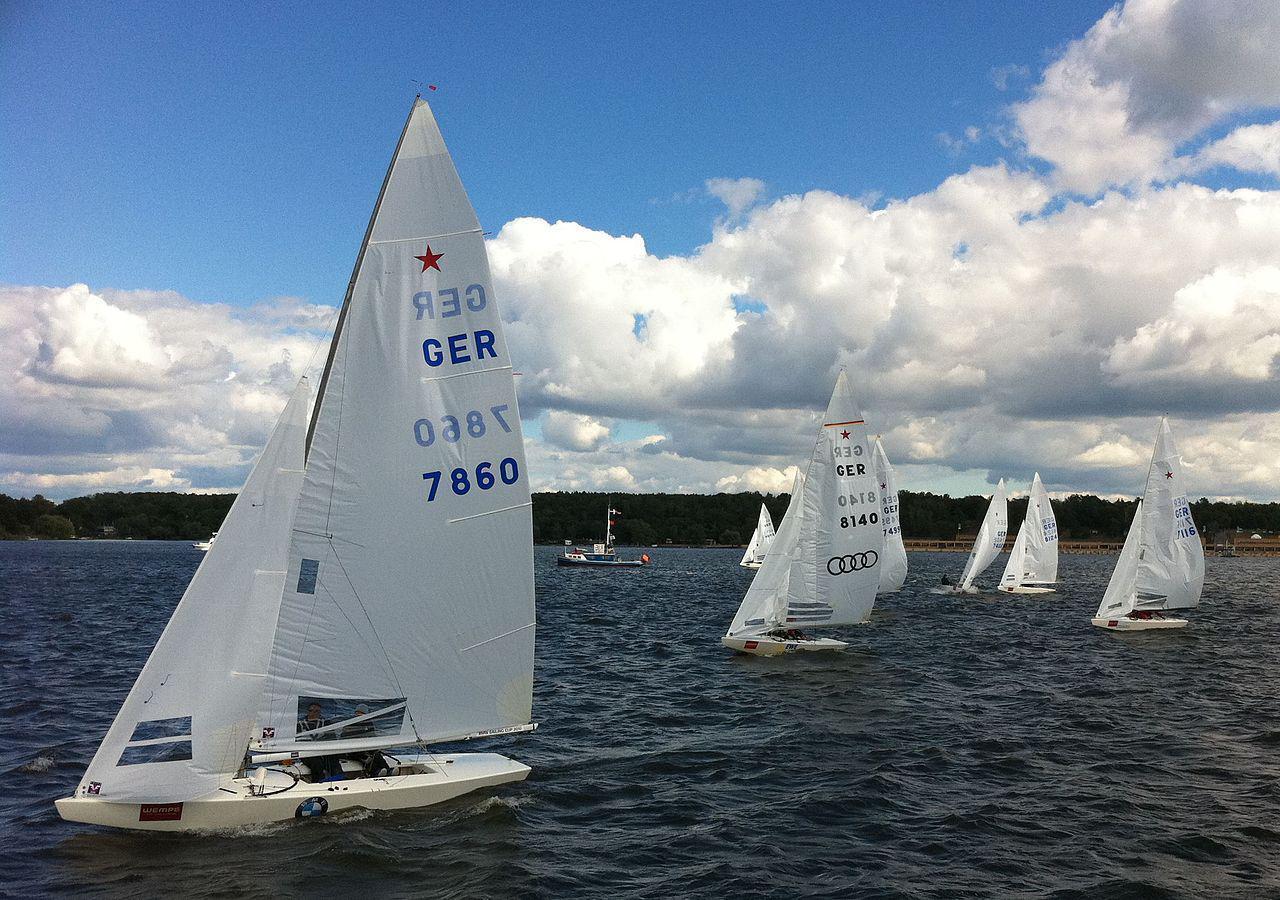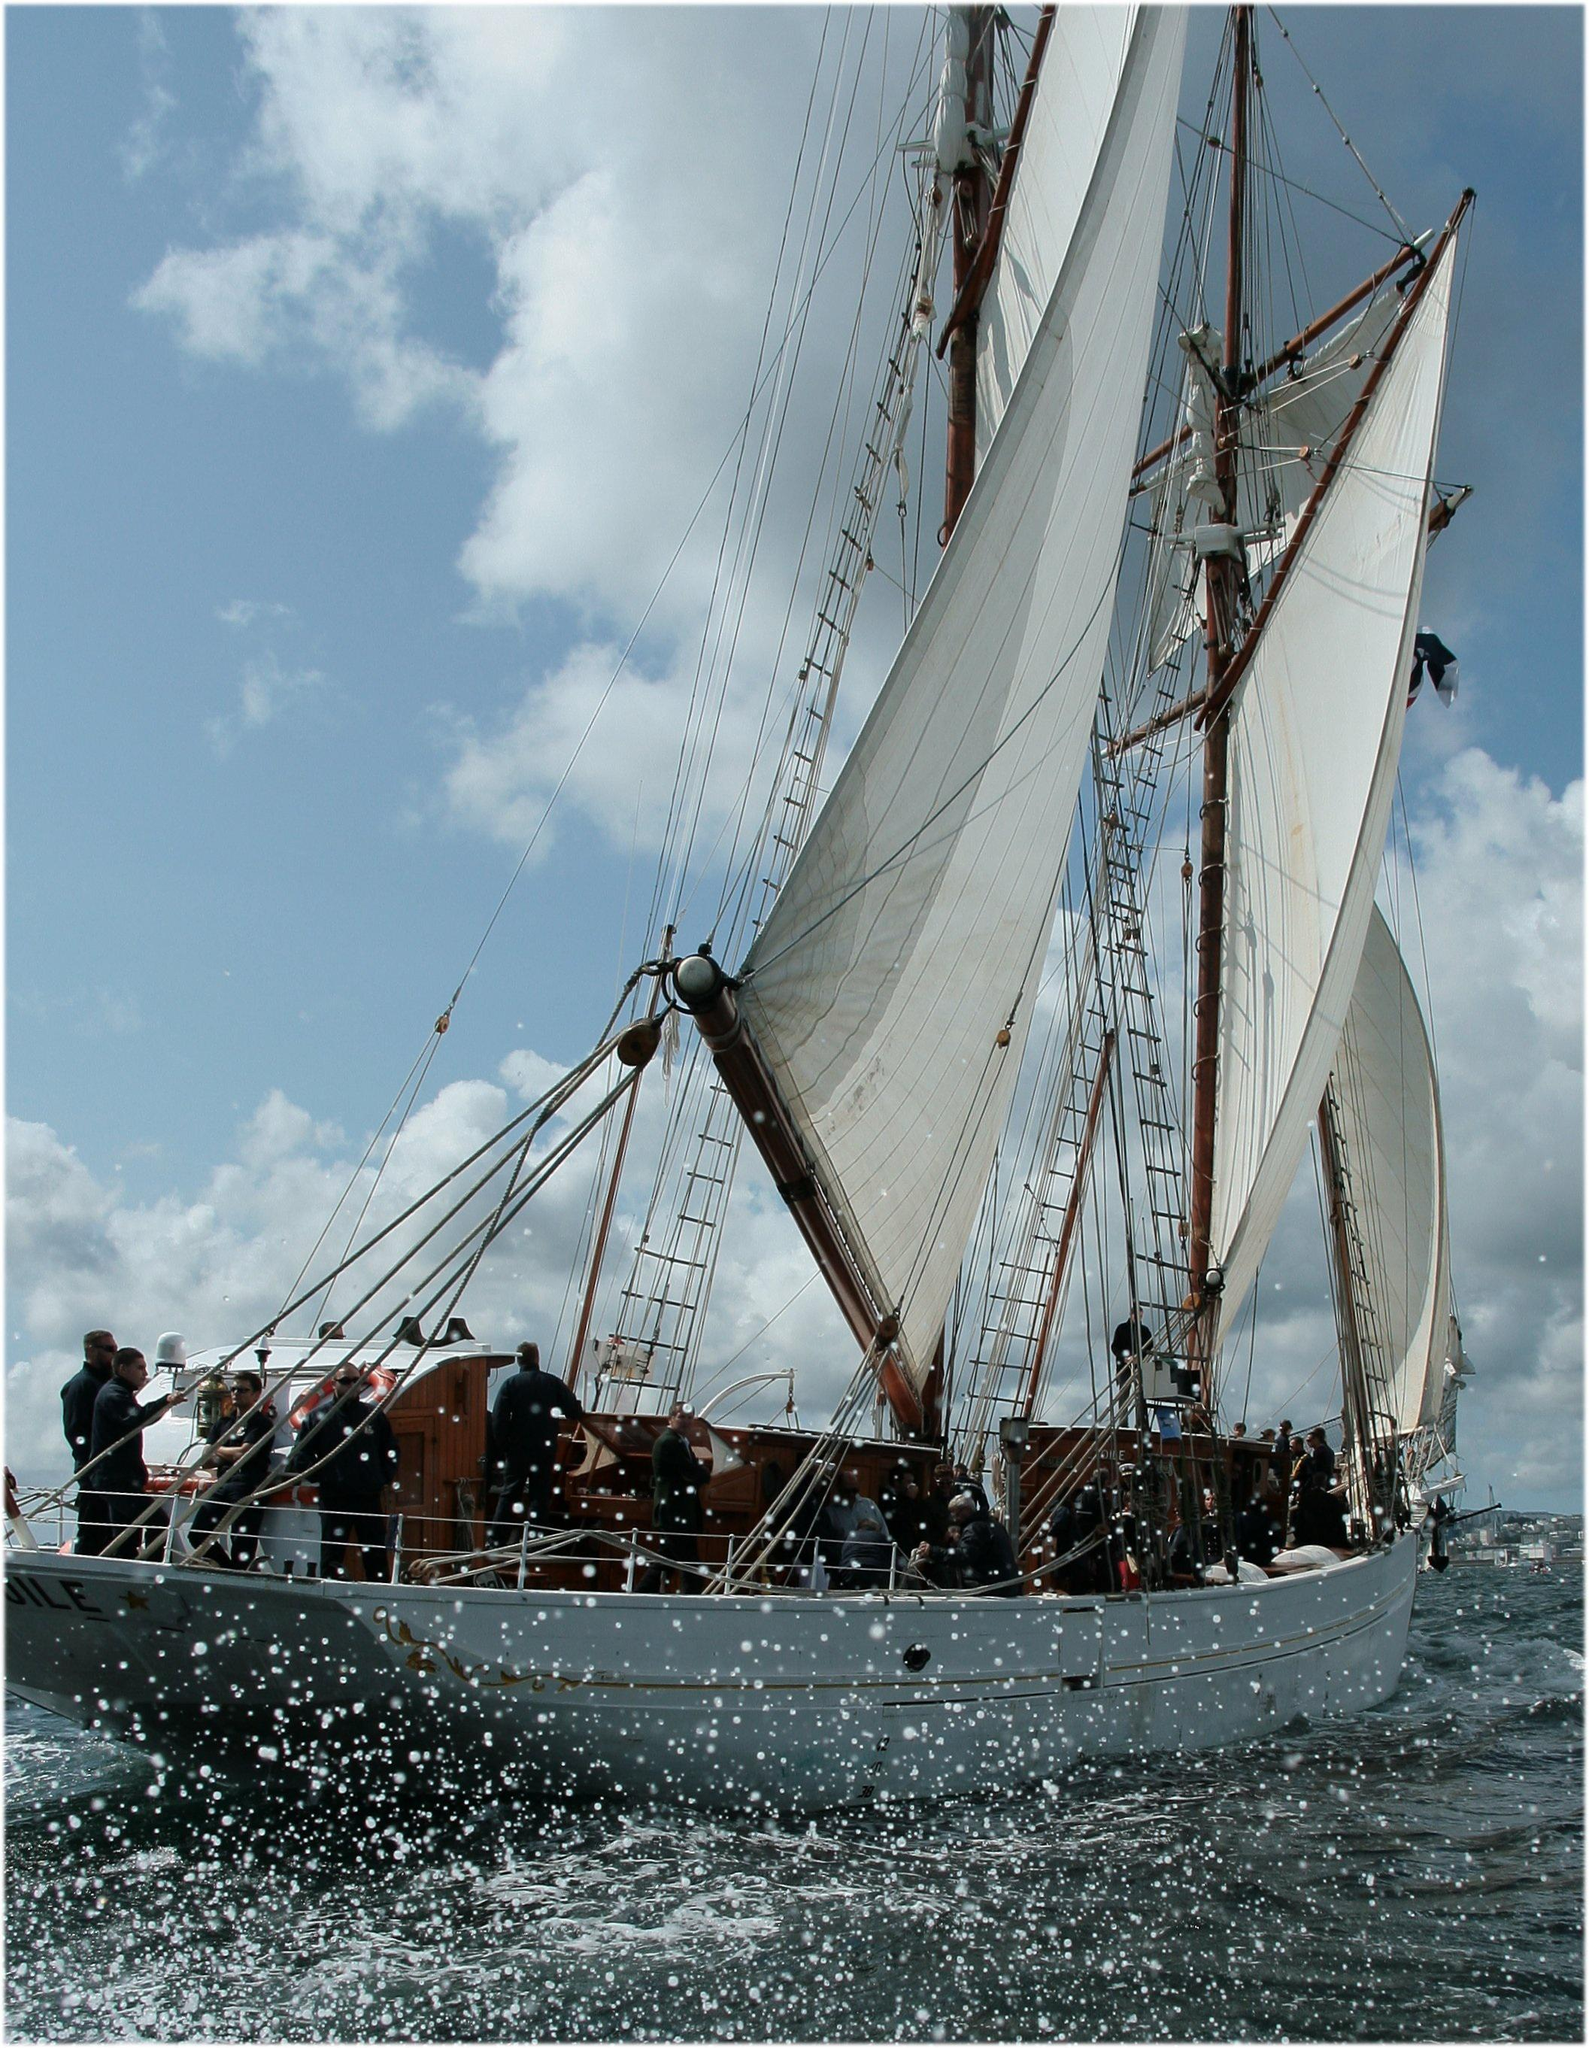The first image is the image on the left, the second image is the image on the right. Examine the images to the left and right. Is the description "There are at least three sailboats on the water." accurate? Answer yes or no. Yes. The first image is the image on the left, the second image is the image on the right. Examine the images to the left and right. Is the description "There are exactly two sailboats on the water." accurate? Answer yes or no. No. 